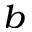Convert formula to latex. <formula><loc_0><loc_0><loc_500><loc_500>^ { b }</formula> 